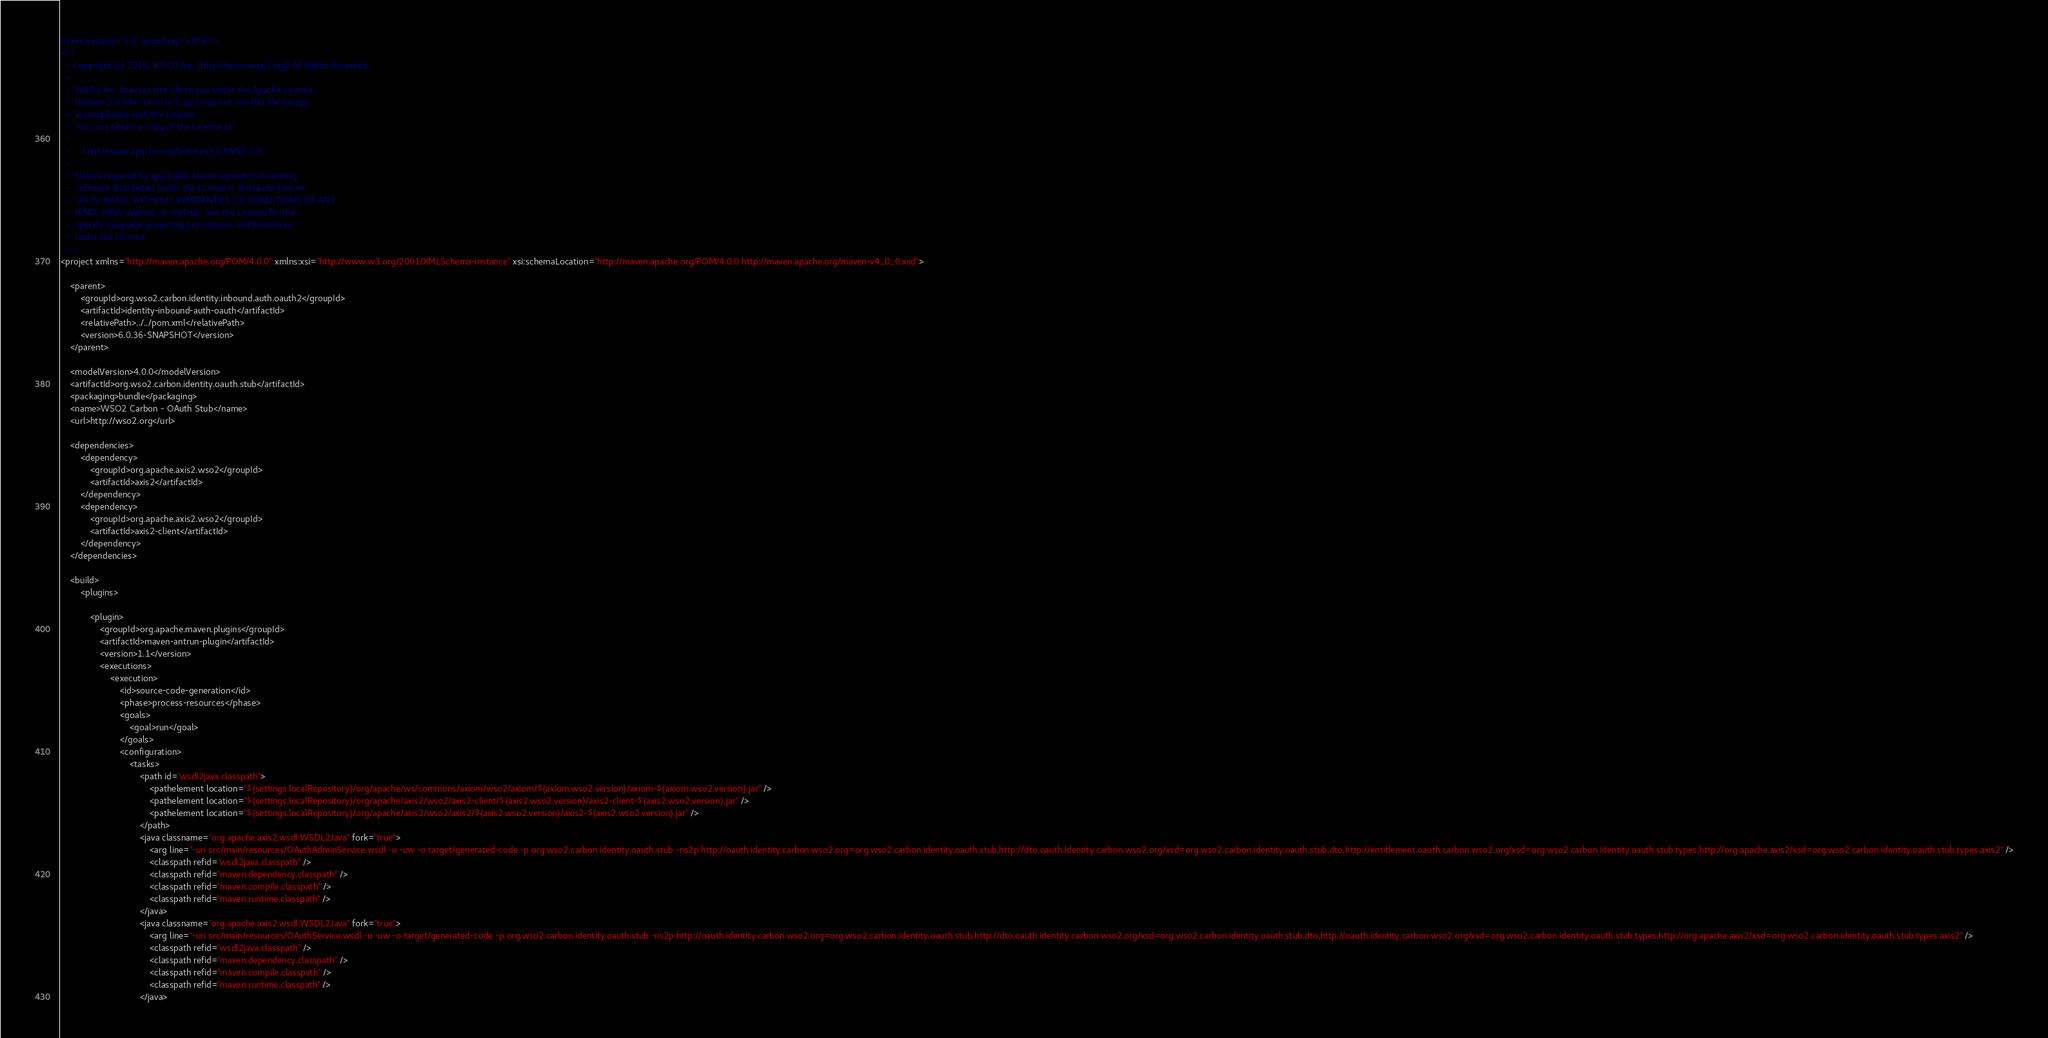<code> <loc_0><loc_0><loc_500><loc_500><_XML_><?xml version="1.0" encoding="utf-8"?>
<!--
  ~ Copyright (c) 2015, WSO2 Inc. (http://www.wso2.org) All Rights Reserved.
  ~
  ~  WSO2 Inc. licenses this file to you under the Apache License,
  ~  Version 2.0 (the "License"); you may not use this file except
  ~  in compliance with the License.
  ~  You may obtain a copy of the License at
  ~
  ~     http://www.apache.org/licenses/LICENSE-2.0
  ~
  ~  Unless required by applicable law or agreed to in writing,
  ~  software distributed under the License is distributed on an
  ~  "AS IS" BASIS, WITHOUT WARRANTIES OR CONDITIONS OF ANY
  ~  KIND, either express or implied.  See the License for the
  ~  specific language governing permissions and limitations
  ~  under the License.
  -->
<project xmlns="http://maven.apache.org/POM/4.0.0" xmlns:xsi="http://www.w3.org/2001/XMLSchema-instance" xsi:schemaLocation="http://maven.apache.org/POM/4.0.0 http://maven.apache.org/maven-v4_0_0.xsd">

    <parent>
        <groupId>org.wso2.carbon.identity.inbound.auth.oauth2</groupId>
        <artifactId>identity-inbound-auth-oauth</artifactId>
        <relativePath>../../pom.xml</relativePath>
        <version>6.0.36-SNAPSHOT</version>
    </parent>

    <modelVersion>4.0.0</modelVersion>
    <artifactId>org.wso2.carbon.identity.oauth.stub</artifactId>
    <packaging>bundle</packaging>
    <name>WSO2 Carbon - OAuth Stub</name>
    <url>http://wso2.org</url>

    <dependencies>
        <dependency>
            <groupId>org.apache.axis2.wso2</groupId>
            <artifactId>axis2</artifactId>
        </dependency>
        <dependency>
            <groupId>org.apache.axis2.wso2</groupId>
            <artifactId>axis2-client</artifactId>
        </dependency>
    </dependencies>

    <build>
        <plugins>

            <plugin>
                <groupId>org.apache.maven.plugins</groupId>
                <artifactId>maven-antrun-plugin</artifactId>
                <version>1.1</version>
                <executions>
                    <execution>
                        <id>source-code-generation</id>
                        <phase>process-resources</phase>
                        <goals>
                            <goal>run</goal>
                        </goals>
                        <configuration>
                            <tasks>
                                <path id="wsdl2java.classpath">
                                    <pathelement location="${settings.localRepository}/org/apache/ws/commons/axiom/wso2/axiom/${axiom.wso2.version}/axiom-${axiom.wso2.version}.jar" />
                                    <pathelement location="${settings.localRepository}/org/apache/axis2/wso2/axis2-client/${axis2.wso2.version}/axis2-client-${axis2.wso2.version}.jar" />
                                    <pathelement location="${settings.localRepository}/org/apache/axis2/wso2/axis2/${axis2.wso2.version}/axis2-${axis2.wso2.version}.jar" />
                                </path>
                                <java classname="org.apache.axis2.wsdl.WSDL2Java" fork="true">
                                    <arg line="-uri src/main/resources/OAuthAdminService.wsdl -u -uw -o target/generated-code -p org.wso2.carbon.identity.oauth.stub -ns2p http://oauth.identity.carbon.wso2.org=org.wso2.carbon.identity.oauth.stub,http://dto.oauth.identity.carbon.wso2.org/xsd=org.wso2.carbon.identity.oauth.stub.dto,http://entitlement.oauth.carbon.wso2.org/xsd=org.wso2.carbon.identity.oauth.stub.types,http://org.apache.axis2/xsd=org.wso2.carbon.identity.oauth.stub.types.axis2" />
                                    <classpath refid="wsdl2java.classpath" />
                                    <classpath refid="maven.dependency.classpath" />
                                    <classpath refid="maven.compile.classpath" />
                                    <classpath refid="maven.runtime.classpath" />
                                </java>
                                <java classname="org.apache.axis2.wsdl.WSDL2Java" fork="true">
                                    <arg line="-uri src/main/resources/OAuthService.wsdl -u -uw -o target/generated-code -p org.wso2.carbon.identity.oauth.stub -ns2p http://oauth.identity.carbon.wso2.org=org.wso2.carbon.identity.oauth.stub,http://dto.oauth.identity.carbon.wso2.org/xsd=org.wso2.carbon.identity.oauth.stub.dto,http://oauth.identity.carbon.wso2.org/xsd=org.wso2.carbon.identity.oauth.stub.types,http://org.apache.axis2/xsd=org.wso2.carbon.identity.oauth.stub.types.axis2" />
                                    <classpath refid="wsdl2java.classpath" />
                                    <classpath refid="maven.dependency.classpath" />
                                    <classpath refid="maven.compile.classpath" />
                                    <classpath refid="maven.runtime.classpath" />
                                </java></code> 